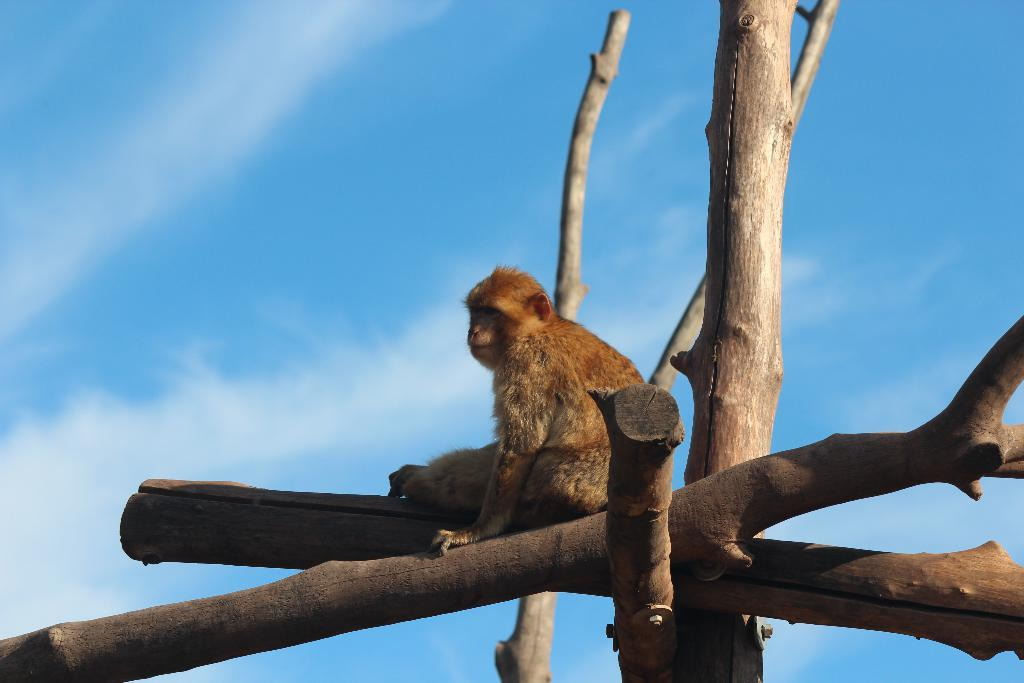What is the main subject in the center of the image? There is a wooden object in the center of the image. What is on top of the wooden object? There is a monkey on the wooden object. What can be seen in the background of the image? The sky is visible in the background of the image, and clouds are present. How many horses are pulling the wooden object in the image? There are no horses present in the image; the wooden object has a monkey on it. What type of yoke is used to connect the horses to the wooden object in the image? There are no horses or yoke present in the image; it features a wooden object with a monkey on it. 